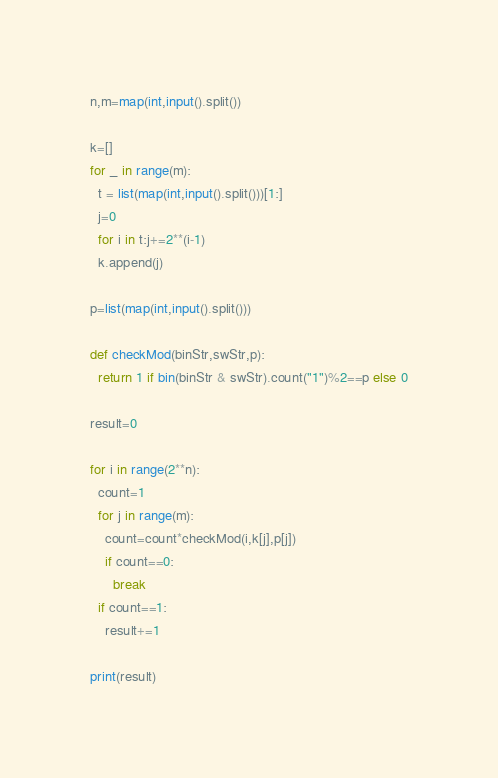<code> <loc_0><loc_0><loc_500><loc_500><_Python_>n,m=map(int,input().split())

k=[]
for _ in range(m):
  t = list(map(int,input().split()))[1:]
  j=0
  for i in t:j+=2**(i-1)
  k.append(j)

p=list(map(int,input().split()))

def checkMod(binStr,swStr,p):
  return 1 if bin(binStr & swStr).count("1")%2==p else 0

result=0

for i in range(2**n):
  count=1
  for j in range(m):
    count=count*checkMod(i,k[j],p[j])
    if count==0:
      break
  if count==1:
    result+=1

print(result)</code> 